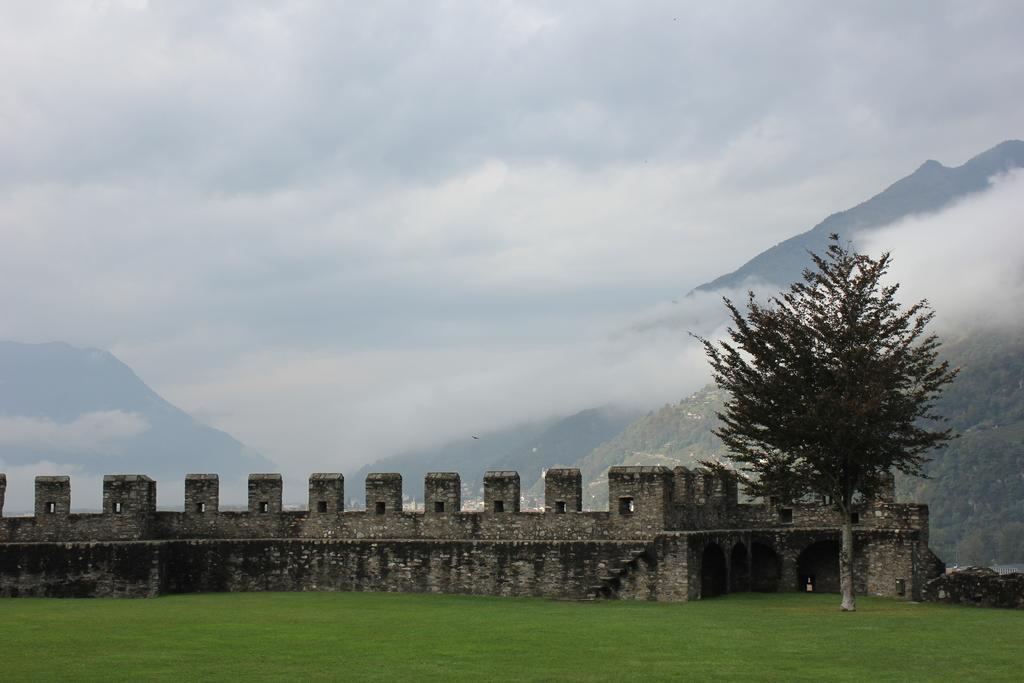What is the primary element visible in the image? The image contains the sky. What can be seen in the sky? Clouds are present in the image. What type of vegetation is visible in the image? There are trees and grass visible in the image. What type of structure is present in the image? A compound wall is present in the image. What type of feather can be seen on the judge's wig in the image? There is no judge or wig present in the image; it features the sky, clouds, trees, grass, and a compound wall. How many geese are visible in the image? There are no geese present in the image. 